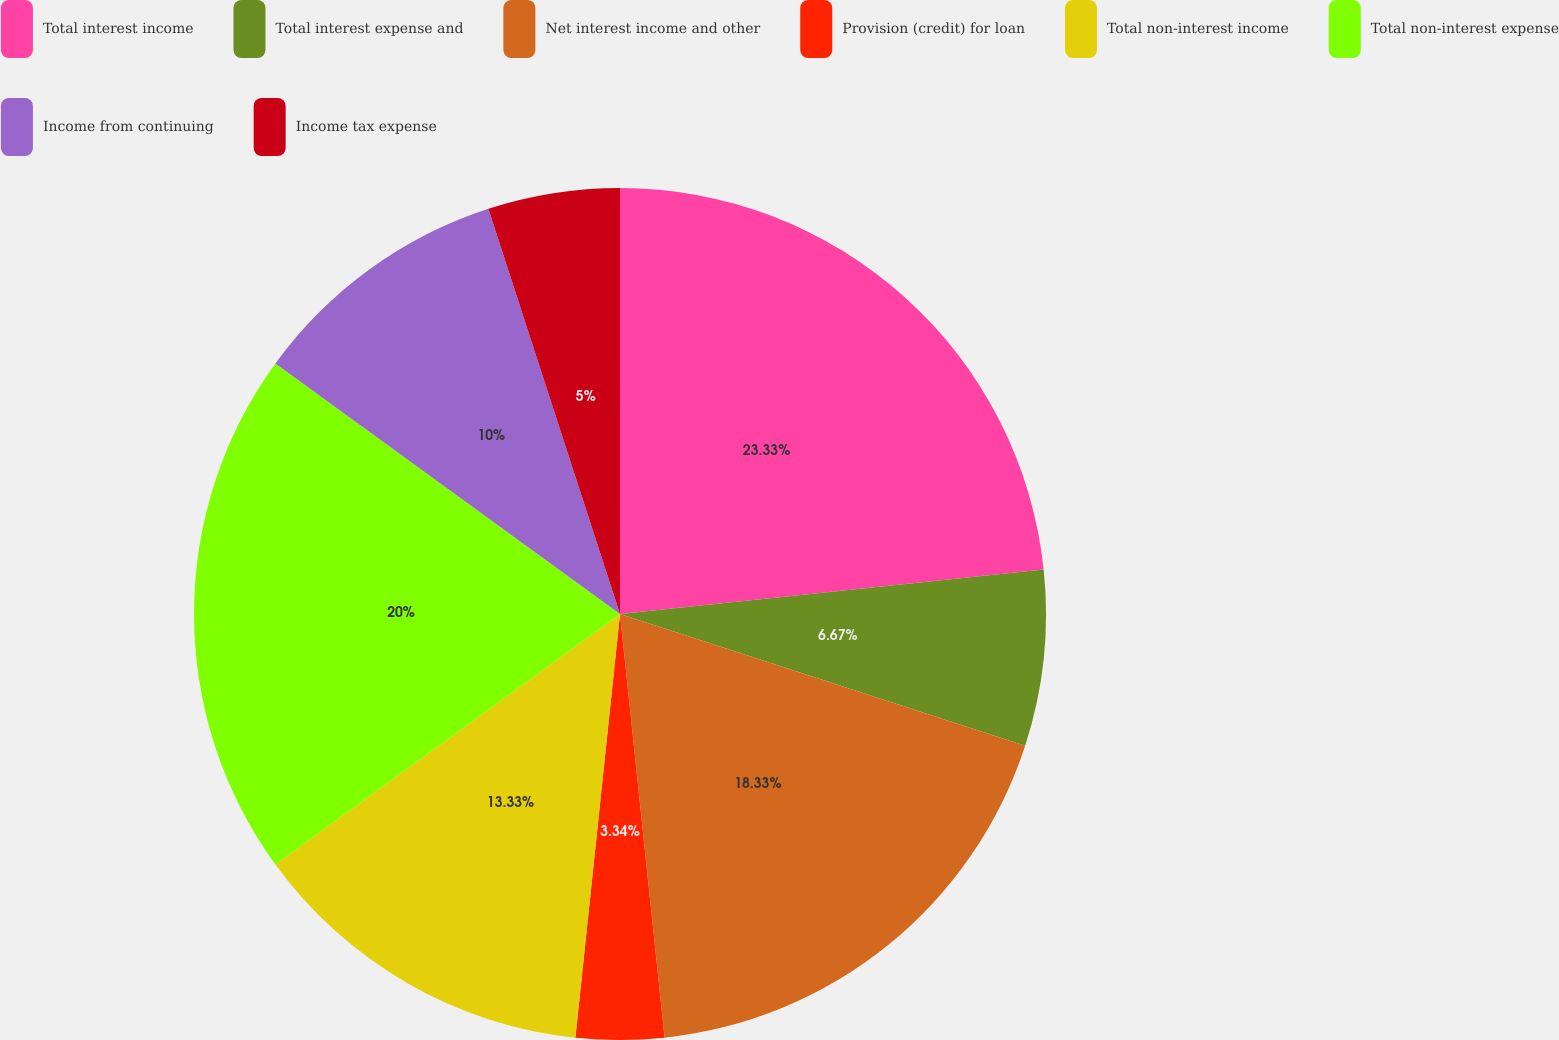<chart> <loc_0><loc_0><loc_500><loc_500><pie_chart><fcel>Total interest income<fcel>Total interest expense and<fcel>Net interest income and other<fcel>Provision (credit) for loan<fcel>Total non-interest income<fcel>Total non-interest expense<fcel>Income from continuing<fcel>Income tax expense<nl><fcel>23.33%<fcel>6.67%<fcel>18.33%<fcel>3.34%<fcel>13.33%<fcel>20.0%<fcel>10.0%<fcel>5.0%<nl></chart> 